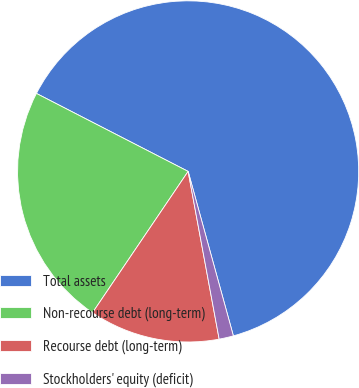Convert chart to OTSL. <chart><loc_0><loc_0><loc_500><loc_500><pie_chart><fcel>Total assets<fcel>Non-recourse debt (long-term)<fcel>Recourse debt (long-term)<fcel>Stockholders' equity (deficit)<nl><fcel>63.17%<fcel>23.09%<fcel>12.38%<fcel>1.36%<nl></chart> 